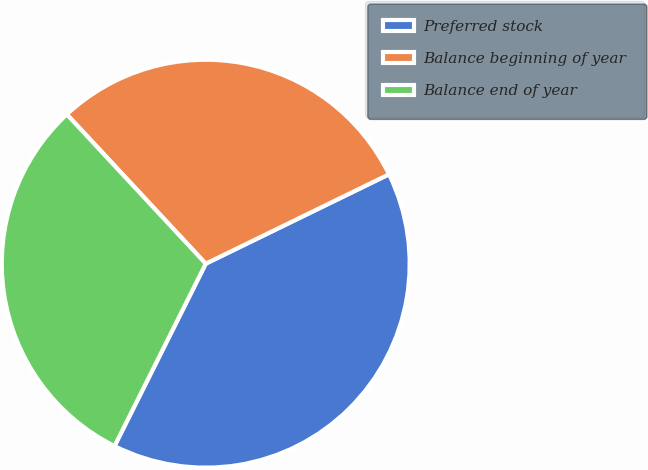<chart> <loc_0><loc_0><loc_500><loc_500><pie_chart><fcel>Preferred stock<fcel>Balance beginning of year<fcel>Balance end of year<nl><fcel>39.6%<fcel>29.7%<fcel>30.69%<nl></chart> 